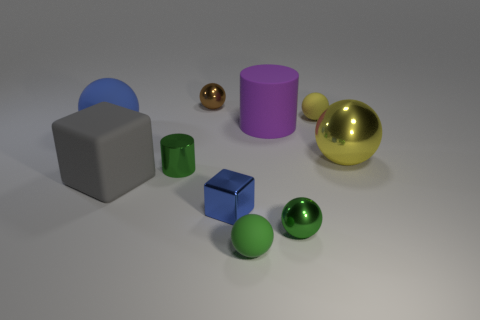There is a cylinder that is made of the same material as the small blue cube; what is its size?
Your answer should be compact. Small. Do the yellow shiny thing and the yellow ball behind the big yellow metal ball have the same size?
Offer a terse response. No. What number of other things are there of the same color as the matte cylinder?
Your answer should be very brief. 0. There is a small brown shiny thing; are there any tiny yellow balls right of it?
Keep it short and to the point. Yes. How many things are either big purple things or cylinders on the left side of the brown metallic object?
Ensure brevity in your answer.  2. There is a big ball that is on the left side of the yellow rubber object; are there any objects on the left side of it?
Keep it short and to the point. No. What is the shape of the tiny green metal object to the right of the sphere in front of the small green metallic object in front of the blue cube?
Make the answer very short. Sphere. There is a sphere that is both in front of the blue matte ball and to the left of the large purple matte object; what color is it?
Provide a succinct answer. Green. What shape is the brown thing behind the small shiny block?
Provide a short and direct response. Sphere. What is the shape of the large purple object that is the same material as the big gray thing?
Give a very brief answer. Cylinder. 